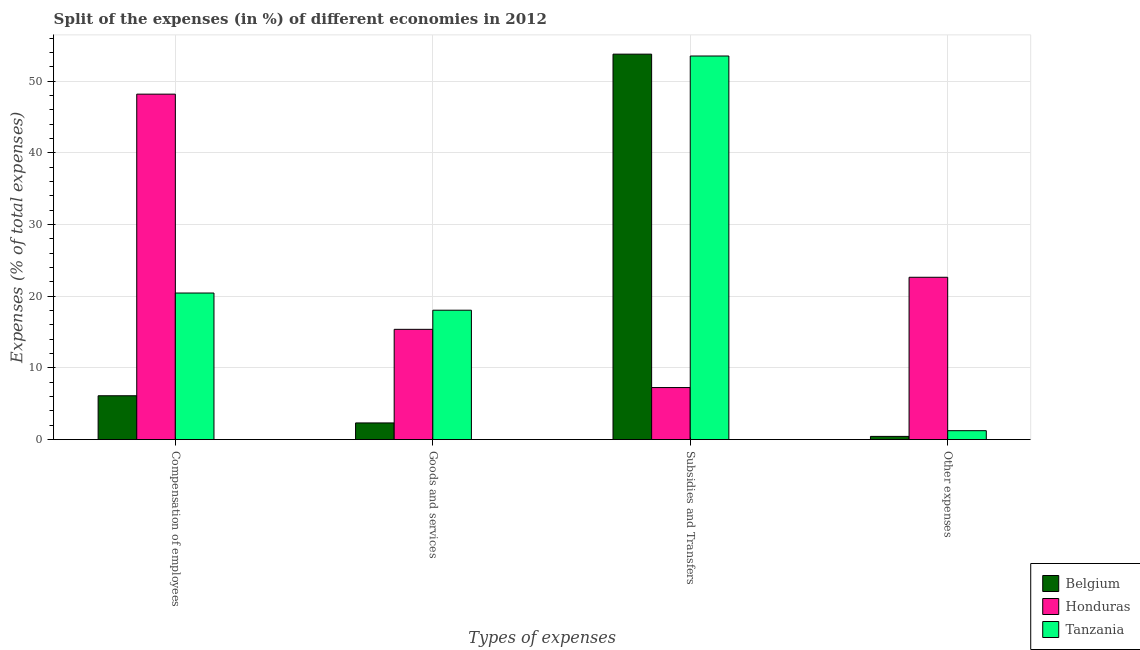How many different coloured bars are there?
Offer a terse response. 3. What is the label of the 2nd group of bars from the left?
Offer a very short reply. Goods and services. What is the percentage of amount spent on subsidies in Tanzania?
Offer a terse response. 53.51. Across all countries, what is the maximum percentage of amount spent on goods and services?
Your response must be concise. 18.05. Across all countries, what is the minimum percentage of amount spent on compensation of employees?
Give a very brief answer. 6.12. In which country was the percentage of amount spent on other expenses maximum?
Your answer should be very brief. Honduras. What is the total percentage of amount spent on other expenses in the graph?
Offer a terse response. 24.33. What is the difference between the percentage of amount spent on other expenses in Belgium and that in Honduras?
Give a very brief answer. -22.2. What is the difference between the percentage of amount spent on compensation of employees in Tanzania and the percentage of amount spent on other expenses in Belgium?
Offer a terse response. 20. What is the average percentage of amount spent on subsidies per country?
Ensure brevity in your answer.  38.18. What is the difference between the percentage of amount spent on other expenses and percentage of amount spent on goods and services in Tanzania?
Give a very brief answer. -16.81. What is the ratio of the percentage of amount spent on subsidies in Honduras to that in Belgium?
Offer a terse response. 0.14. Is the difference between the percentage of amount spent on compensation of employees in Belgium and Honduras greater than the difference between the percentage of amount spent on other expenses in Belgium and Honduras?
Offer a very short reply. No. What is the difference between the highest and the second highest percentage of amount spent on other expenses?
Your answer should be compact. 21.4. What is the difference between the highest and the lowest percentage of amount spent on subsidies?
Offer a very short reply. 46.51. Is the sum of the percentage of amount spent on subsidies in Honduras and Tanzania greater than the maximum percentage of amount spent on other expenses across all countries?
Provide a short and direct response. Yes. What does the 3rd bar from the right in Other expenses represents?
Your answer should be very brief. Belgium. Is it the case that in every country, the sum of the percentage of amount spent on compensation of employees and percentage of amount spent on goods and services is greater than the percentage of amount spent on subsidies?
Keep it short and to the point. No. Are all the bars in the graph horizontal?
Keep it short and to the point. No. What is the difference between two consecutive major ticks on the Y-axis?
Your response must be concise. 10. Are the values on the major ticks of Y-axis written in scientific E-notation?
Provide a succinct answer. No. Does the graph contain any zero values?
Offer a terse response. No. Where does the legend appear in the graph?
Your answer should be compact. Bottom right. How are the legend labels stacked?
Your answer should be compact. Vertical. What is the title of the graph?
Make the answer very short. Split of the expenses (in %) of different economies in 2012. What is the label or title of the X-axis?
Provide a succinct answer. Types of expenses. What is the label or title of the Y-axis?
Provide a succinct answer. Expenses (% of total expenses). What is the Expenses (% of total expenses) in Belgium in Compensation of employees?
Ensure brevity in your answer.  6.12. What is the Expenses (% of total expenses) of Honduras in Compensation of employees?
Your answer should be very brief. 48.19. What is the Expenses (% of total expenses) of Tanzania in Compensation of employees?
Provide a short and direct response. 20.45. What is the Expenses (% of total expenses) in Belgium in Goods and services?
Make the answer very short. 2.33. What is the Expenses (% of total expenses) in Honduras in Goods and services?
Provide a short and direct response. 15.38. What is the Expenses (% of total expenses) in Tanzania in Goods and services?
Your answer should be compact. 18.05. What is the Expenses (% of total expenses) in Belgium in Subsidies and Transfers?
Ensure brevity in your answer.  53.77. What is the Expenses (% of total expenses) in Honduras in Subsidies and Transfers?
Offer a terse response. 7.26. What is the Expenses (% of total expenses) in Tanzania in Subsidies and Transfers?
Your answer should be compact. 53.51. What is the Expenses (% of total expenses) in Belgium in Other expenses?
Your answer should be compact. 0.45. What is the Expenses (% of total expenses) in Honduras in Other expenses?
Ensure brevity in your answer.  22.64. What is the Expenses (% of total expenses) of Tanzania in Other expenses?
Ensure brevity in your answer.  1.24. Across all Types of expenses, what is the maximum Expenses (% of total expenses) in Belgium?
Provide a short and direct response. 53.77. Across all Types of expenses, what is the maximum Expenses (% of total expenses) in Honduras?
Ensure brevity in your answer.  48.19. Across all Types of expenses, what is the maximum Expenses (% of total expenses) of Tanzania?
Give a very brief answer. 53.51. Across all Types of expenses, what is the minimum Expenses (% of total expenses) of Belgium?
Provide a short and direct response. 0.45. Across all Types of expenses, what is the minimum Expenses (% of total expenses) in Honduras?
Offer a very short reply. 7.26. Across all Types of expenses, what is the minimum Expenses (% of total expenses) of Tanzania?
Keep it short and to the point. 1.24. What is the total Expenses (% of total expenses) in Belgium in the graph?
Provide a succinct answer. 62.66. What is the total Expenses (% of total expenses) of Honduras in the graph?
Give a very brief answer. 93.48. What is the total Expenses (% of total expenses) in Tanzania in the graph?
Ensure brevity in your answer.  93.25. What is the difference between the Expenses (% of total expenses) of Belgium in Compensation of employees and that in Goods and services?
Provide a short and direct response. 3.79. What is the difference between the Expenses (% of total expenses) in Honduras in Compensation of employees and that in Goods and services?
Give a very brief answer. 32.81. What is the difference between the Expenses (% of total expenses) of Tanzania in Compensation of employees and that in Goods and services?
Give a very brief answer. 2.4. What is the difference between the Expenses (% of total expenses) of Belgium in Compensation of employees and that in Subsidies and Transfers?
Provide a short and direct response. -47.65. What is the difference between the Expenses (% of total expenses) in Honduras in Compensation of employees and that in Subsidies and Transfers?
Ensure brevity in your answer.  40.93. What is the difference between the Expenses (% of total expenses) in Tanzania in Compensation of employees and that in Subsidies and Transfers?
Offer a terse response. -33.06. What is the difference between the Expenses (% of total expenses) in Belgium in Compensation of employees and that in Other expenses?
Your answer should be compact. 5.67. What is the difference between the Expenses (% of total expenses) in Honduras in Compensation of employees and that in Other expenses?
Offer a terse response. 25.55. What is the difference between the Expenses (% of total expenses) in Tanzania in Compensation of employees and that in Other expenses?
Offer a terse response. 19.2. What is the difference between the Expenses (% of total expenses) of Belgium in Goods and services and that in Subsidies and Transfers?
Keep it short and to the point. -51.44. What is the difference between the Expenses (% of total expenses) in Honduras in Goods and services and that in Subsidies and Transfers?
Your response must be concise. 8.12. What is the difference between the Expenses (% of total expenses) in Tanzania in Goods and services and that in Subsidies and Transfers?
Provide a succinct answer. -35.46. What is the difference between the Expenses (% of total expenses) in Belgium in Goods and services and that in Other expenses?
Keep it short and to the point. 1.88. What is the difference between the Expenses (% of total expenses) of Honduras in Goods and services and that in Other expenses?
Your response must be concise. -7.26. What is the difference between the Expenses (% of total expenses) of Tanzania in Goods and services and that in Other expenses?
Your answer should be compact. 16.81. What is the difference between the Expenses (% of total expenses) in Belgium in Subsidies and Transfers and that in Other expenses?
Provide a short and direct response. 53.32. What is the difference between the Expenses (% of total expenses) in Honduras in Subsidies and Transfers and that in Other expenses?
Your answer should be compact. -15.38. What is the difference between the Expenses (% of total expenses) in Tanzania in Subsidies and Transfers and that in Other expenses?
Make the answer very short. 52.27. What is the difference between the Expenses (% of total expenses) in Belgium in Compensation of employees and the Expenses (% of total expenses) in Honduras in Goods and services?
Keep it short and to the point. -9.27. What is the difference between the Expenses (% of total expenses) in Belgium in Compensation of employees and the Expenses (% of total expenses) in Tanzania in Goods and services?
Provide a short and direct response. -11.93. What is the difference between the Expenses (% of total expenses) in Honduras in Compensation of employees and the Expenses (% of total expenses) in Tanzania in Goods and services?
Make the answer very short. 30.14. What is the difference between the Expenses (% of total expenses) of Belgium in Compensation of employees and the Expenses (% of total expenses) of Honduras in Subsidies and Transfers?
Keep it short and to the point. -1.14. What is the difference between the Expenses (% of total expenses) of Belgium in Compensation of employees and the Expenses (% of total expenses) of Tanzania in Subsidies and Transfers?
Your response must be concise. -47.39. What is the difference between the Expenses (% of total expenses) of Honduras in Compensation of employees and the Expenses (% of total expenses) of Tanzania in Subsidies and Transfers?
Your response must be concise. -5.32. What is the difference between the Expenses (% of total expenses) of Belgium in Compensation of employees and the Expenses (% of total expenses) of Honduras in Other expenses?
Make the answer very short. -16.53. What is the difference between the Expenses (% of total expenses) in Belgium in Compensation of employees and the Expenses (% of total expenses) in Tanzania in Other expenses?
Offer a very short reply. 4.87. What is the difference between the Expenses (% of total expenses) of Honduras in Compensation of employees and the Expenses (% of total expenses) of Tanzania in Other expenses?
Ensure brevity in your answer.  46.95. What is the difference between the Expenses (% of total expenses) of Belgium in Goods and services and the Expenses (% of total expenses) of Honduras in Subsidies and Transfers?
Ensure brevity in your answer.  -4.93. What is the difference between the Expenses (% of total expenses) in Belgium in Goods and services and the Expenses (% of total expenses) in Tanzania in Subsidies and Transfers?
Give a very brief answer. -51.18. What is the difference between the Expenses (% of total expenses) of Honduras in Goods and services and the Expenses (% of total expenses) of Tanzania in Subsidies and Transfers?
Offer a very short reply. -38.13. What is the difference between the Expenses (% of total expenses) of Belgium in Goods and services and the Expenses (% of total expenses) of Honduras in Other expenses?
Your answer should be compact. -20.32. What is the difference between the Expenses (% of total expenses) in Belgium in Goods and services and the Expenses (% of total expenses) in Tanzania in Other expenses?
Provide a short and direct response. 1.08. What is the difference between the Expenses (% of total expenses) in Honduras in Goods and services and the Expenses (% of total expenses) in Tanzania in Other expenses?
Give a very brief answer. 14.14. What is the difference between the Expenses (% of total expenses) in Belgium in Subsidies and Transfers and the Expenses (% of total expenses) in Honduras in Other expenses?
Offer a very short reply. 31.13. What is the difference between the Expenses (% of total expenses) in Belgium in Subsidies and Transfers and the Expenses (% of total expenses) in Tanzania in Other expenses?
Give a very brief answer. 52.53. What is the difference between the Expenses (% of total expenses) in Honduras in Subsidies and Transfers and the Expenses (% of total expenses) in Tanzania in Other expenses?
Provide a short and direct response. 6.02. What is the average Expenses (% of total expenses) of Belgium per Types of expenses?
Your answer should be compact. 15.66. What is the average Expenses (% of total expenses) of Honduras per Types of expenses?
Your response must be concise. 23.37. What is the average Expenses (% of total expenses) in Tanzania per Types of expenses?
Provide a succinct answer. 23.31. What is the difference between the Expenses (% of total expenses) of Belgium and Expenses (% of total expenses) of Honduras in Compensation of employees?
Your response must be concise. -42.07. What is the difference between the Expenses (% of total expenses) of Belgium and Expenses (% of total expenses) of Tanzania in Compensation of employees?
Give a very brief answer. -14.33. What is the difference between the Expenses (% of total expenses) of Honduras and Expenses (% of total expenses) of Tanzania in Compensation of employees?
Offer a very short reply. 27.74. What is the difference between the Expenses (% of total expenses) of Belgium and Expenses (% of total expenses) of Honduras in Goods and services?
Your answer should be very brief. -13.06. What is the difference between the Expenses (% of total expenses) in Belgium and Expenses (% of total expenses) in Tanzania in Goods and services?
Provide a succinct answer. -15.72. What is the difference between the Expenses (% of total expenses) of Honduras and Expenses (% of total expenses) of Tanzania in Goods and services?
Ensure brevity in your answer.  -2.67. What is the difference between the Expenses (% of total expenses) in Belgium and Expenses (% of total expenses) in Honduras in Subsidies and Transfers?
Your answer should be compact. 46.51. What is the difference between the Expenses (% of total expenses) of Belgium and Expenses (% of total expenses) of Tanzania in Subsidies and Transfers?
Make the answer very short. 0.26. What is the difference between the Expenses (% of total expenses) of Honduras and Expenses (% of total expenses) of Tanzania in Subsidies and Transfers?
Your response must be concise. -46.25. What is the difference between the Expenses (% of total expenses) of Belgium and Expenses (% of total expenses) of Honduras in Other expenses?
Provide a succinct answer. -22.2. What is the difference between the Expenses (% of total expenses) of Belgium and Expenses (% of total expenses) of Tanzania in Other expenses?
Your answer should be very brief. -0.8. What is the difference between the Expenses (% of total expenses) of Honduras and Expenses (% of total expenses) of Tanzania in Other expenses?
Make the answer very short. 21.4. What is the ratio of the Expenses (% of total expenses) of Belgium in Compensation of employees to that in Goods and services?
Provide a succinct answer. 2.63. What is the ratio of the Expenses (% of total expenses) in Honduras in Compensation of employees to that in Goods and services?
Provide a short and direct response. 3.13. What is the ratio of the Expenses (% of total expenses) in Tanzania in Compensation of employees to that in Goods and services?
Your answer should be very brief. 1.13. What is the ratio of the Expenses (% of total expenses) in Belgium in Compensation of employees to that in Subsidies and Transfers?
Your answer should be very brief. 0.11. What is the ratio of the Expenses (% of total expenses) of Honduras in Compensation of employees to that in Subsidies and Transfers?
Your answer should be very brief. 6.64. What is the ratio of the Expenses (% of total expenses) of Tanzania in Compensation of employees to that in Subsidies and Transfers?
Offer a very short reply. 0.38. What is the ratio of the Expenses (% of total expenses) of Belgium in Compensation of employees to that in Other expenses?
Provide a succinct answer. 13.71. What is the ratio of the Expenses (% of total expenses) of Honduras in Compensation of employees to that in Other expenses?
Offer a terse response. 2.13. What is the ratio of the Expenses (% of total expenses) of Tanzania in Compensation of employees to that in Other expenses?
Offer a very short reply. 16.44. What is the ratio of the Expenses (% of total expenses) in Belgium in Goods and services to that in Subsidies and Transfers?
Keep it short and to the point. 0.04. What is the ratio of the Expenses (% of total expenses) in Honduras in Goods and services to that in Subsidies and Transfers?
Your answer should be compact. 2.12. What is the ratio of the Expenses (% of total expenses) of Tanzania in Goods and services to that in Subsidies and Transfers?
Your answer should be compact. 0.34. What is the ratio of the Expenses (% of total expenses) in Belgium in Goods and services to that in Other expenses?
Offer a terse response. 5.21. What is the ratio of the Expenses (% of total expenses) in Honduras in Goods and services to that in Other expenses?
Provide a short and direct response. 0.68. What is the ratio of the Expenses (% of total expenses) of Tanzania in Goods and services to that in Other expenses?
Offer a very short reply. 14.51. What is the ratio of the Expenses (% of total expenses) of Belgium in Subsidies and Transfers to that in Other expenses?
Offer a terse response. 120.46. What is the ratio of the Expenses (% of total expenses) of Honduras in Subsidies and Transfers to that in Other expenses?
Your answer should be compact. 0.32. What is the ratio of the Expenses (% of total expenses) in Tanzania in Subsidies and Transfers to that in Other expenses?
Offer a very short reply. 43.01. What is the difference between the highest and the second highest Expenses (% of total expenses) in Belgium?
Your answer should be very brief. 47.65. What is the difference between the highest and the second highest Expenses (% of total expenses) in Honduras?
Keep it short and to the point. 25.55. What is the difference between the highest and the second highest Expenses (% of total expenses) of Tanzania?
Provide a succinct answer. 33.06. What is the difference between the highest and the lowest Expenses (% of total expenses) in Belgium?
Make the answer very short. 53.32. What is the difference between the highest and the lowest Expenses (% of total expenses) of Honduras?
Provide a short and direct response. 40.93. What is the difference between the highest and the lowest Expenses (% of total expenses) in Tanzania?
Give a very brief answer. 52.27. 